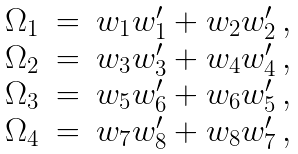Convert formula to latex. <formula><loc_0><loc_0><loc_500><loc_500>\begin{array} { l l l } \Omega _ { 1 } & = & w _ { 1 } w _ { 1 } ^ { \prime } + w _ { 2 } w _ { 2 } ^ { \prime } \, , \\ \Omega _ { 2 } & = & w _ { 3 } w _ { 3 } ^ { \prime } + w _ { 4 } w _ { 4 } ^ { \prime } \, , \\ \Omega _ { 3 } & = & w _ { 5 } w _ { 6 } ^ { \prime } + w _ { 6 } w _ { 5 } ^ { \prime } \, , \\ \Omega _ { 4 } & = & w _ { 7 } w _ { 8 } ^ { \prime } + w _ { 8 } w _ { 7 } ^ { \prime } \, , \end{array}</formula> 